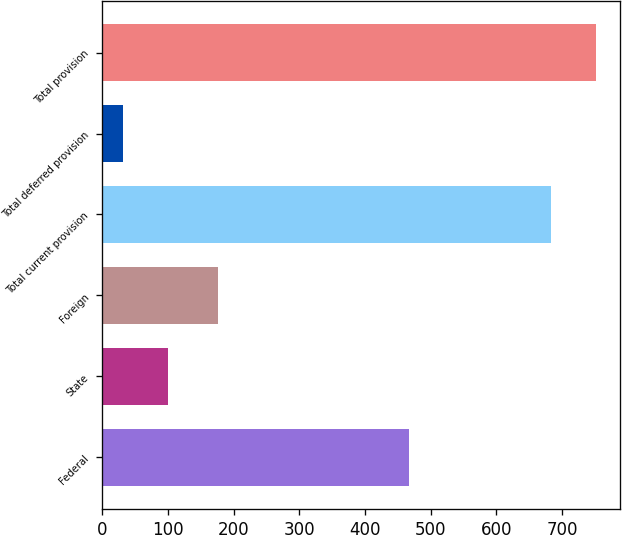Convert chart. <chart><loc_0><loc_0><loc_500><loc_500><bar_chart><fcel>Federal<fcel>State<fcel>Foreign<fcel>Total current provision<fcel>Total deferred provision<fcel>Total provision<nl><fcel>467<fcel>100.3<fcel>176<fcel>683<fcel>32<fcel>751.3<nl></chart> 